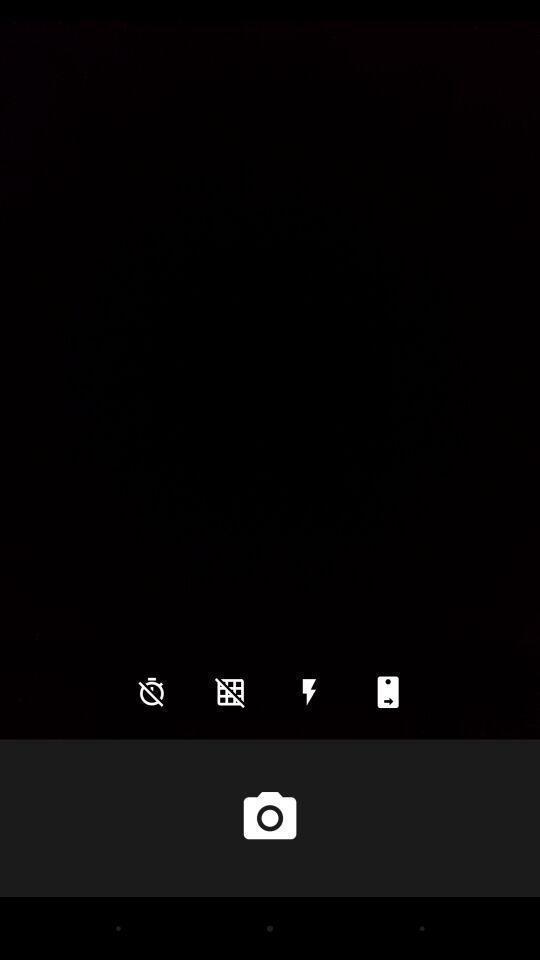Describe the key features of this screenshot. Page showing blank camera screen. 